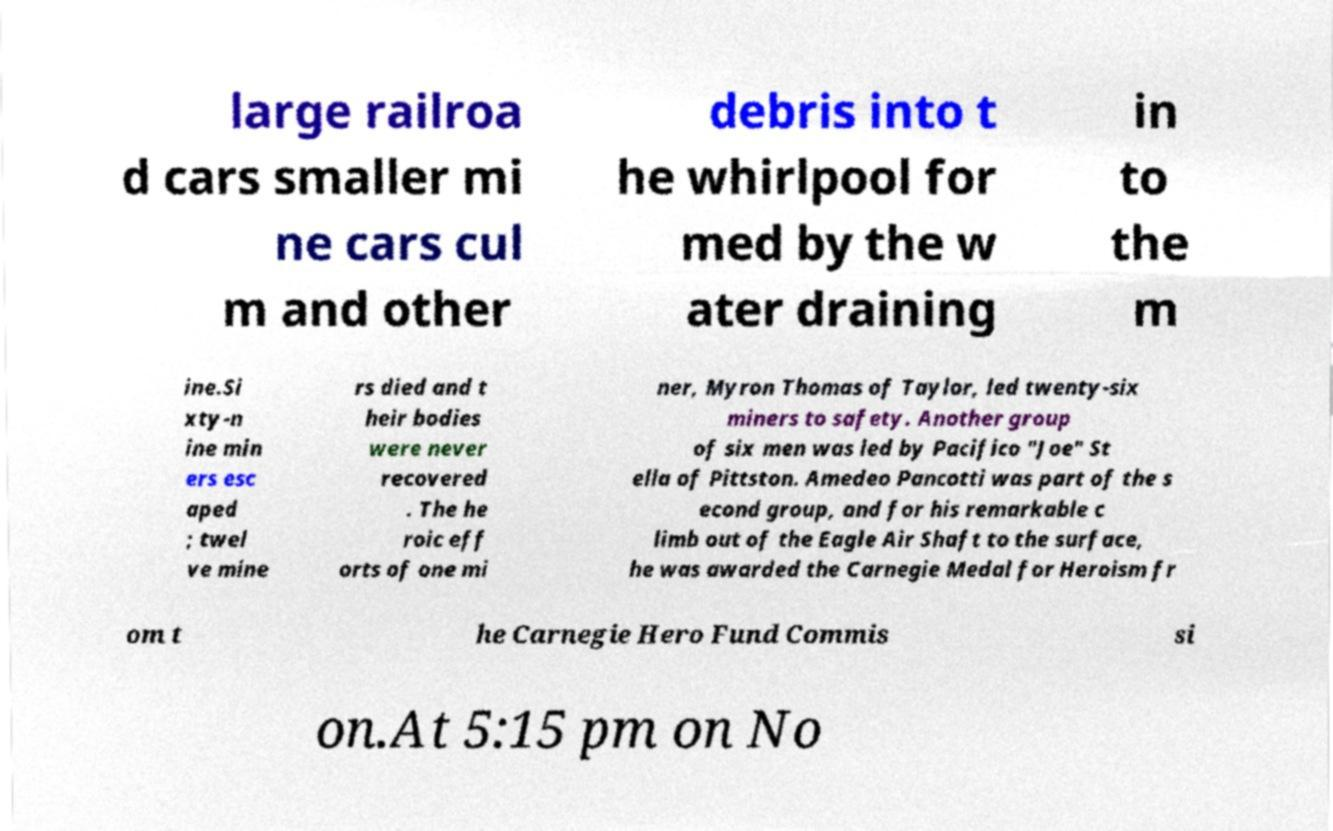Please identify and transcribe the text found in this image. large railroa d cars smaller mi ne cars cul m and other debris into t he whirlpool for med by the w ater draining in to the m ine.Si xty-n ine min ers esc aped ; twel ve mine rs died and t heir bodies were never recovered . The he roic eff orts of one mi ner, Myron Thomas of Taylor, led twenty-six miners to safety. Another group of six men was led by Pacifico "Joe" St ella of Pittston. Amedeo Pancotti was part of the s econd group, and for his remarkable c limb out of the Eagle Air Shaft to the surface, he was awarded the Carnegie Medal for Heroism fr om t he Carnegie Hero Fund Commis si on.At 5:15 pm on No 